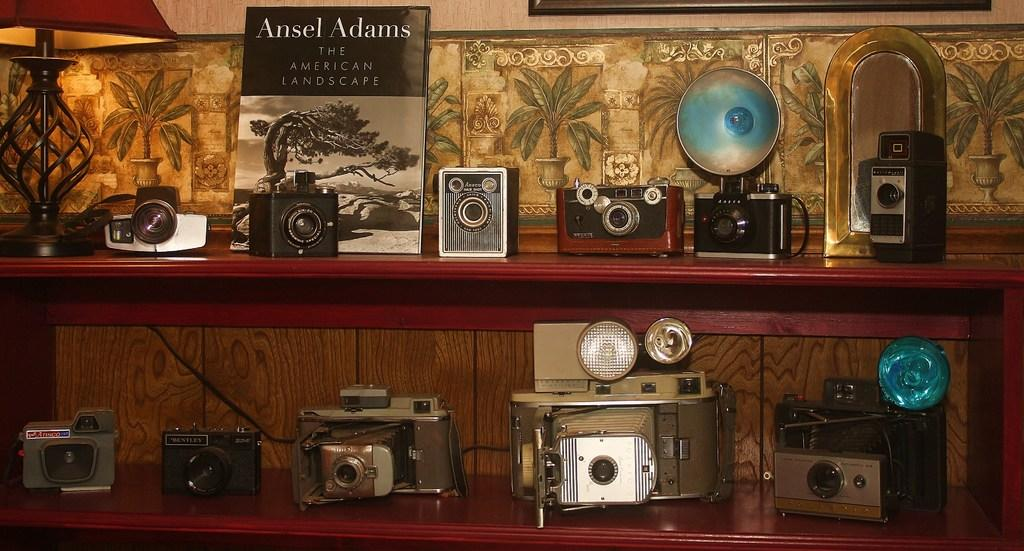<image>
Summarize the visual content of the image. Book behind a camera that says "Ansel Adams" on it. 